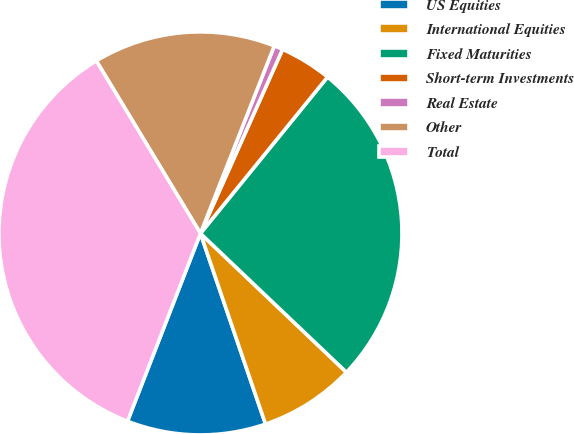<chart> <loc_0><loc_0><loc_500><loc_500><pie_chart><fcel>US Equities<fcel>International Equities<fcel>Fixed Maturities<fcel>Short-term Investments<fcel>Real Estate<fcel>Other<fcel>Total<nl><fcel>11.13%<fcel>7.66%<fcel>26.24%<fcel>4.18%<fcel>0.71%<fcel>14.61%<fcel>35.46%<nl></chart> 